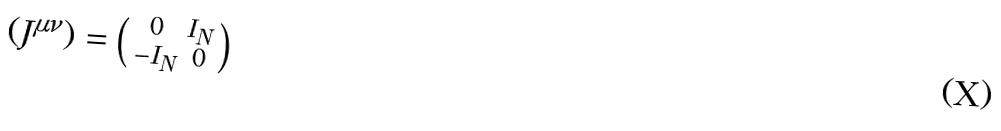<formula> <loc_0><loc_0><loc_500><loc_500>( J ^ { \mu \nu } ) = \left ( \begin{smallmatrix} 0 & I _ { N } \\ - I _ { N } & 0 \end{smallmatrix} \right )</formula> 